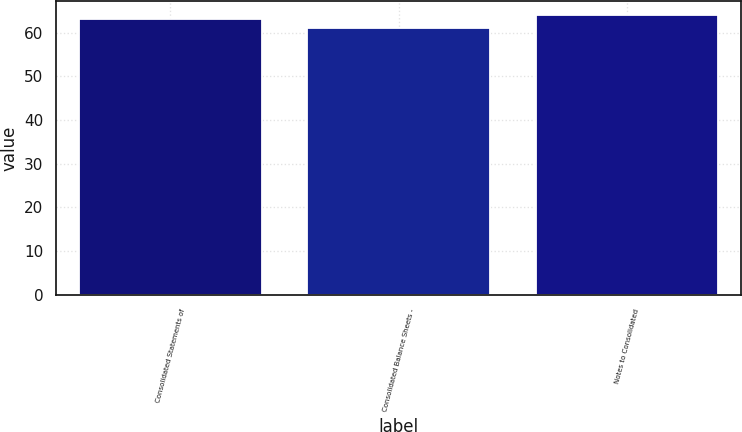Convert chart to OTSL. <chart><loc_0><loc_0><loc_500><loc_500><bar_chart><fcel>Consolidated Statements of<fcel>Consolidated Balance Sheets -<fcel>Notes to Consolidated<nl><fcel>63<fcel>61<fcel>64<nl></chart> 